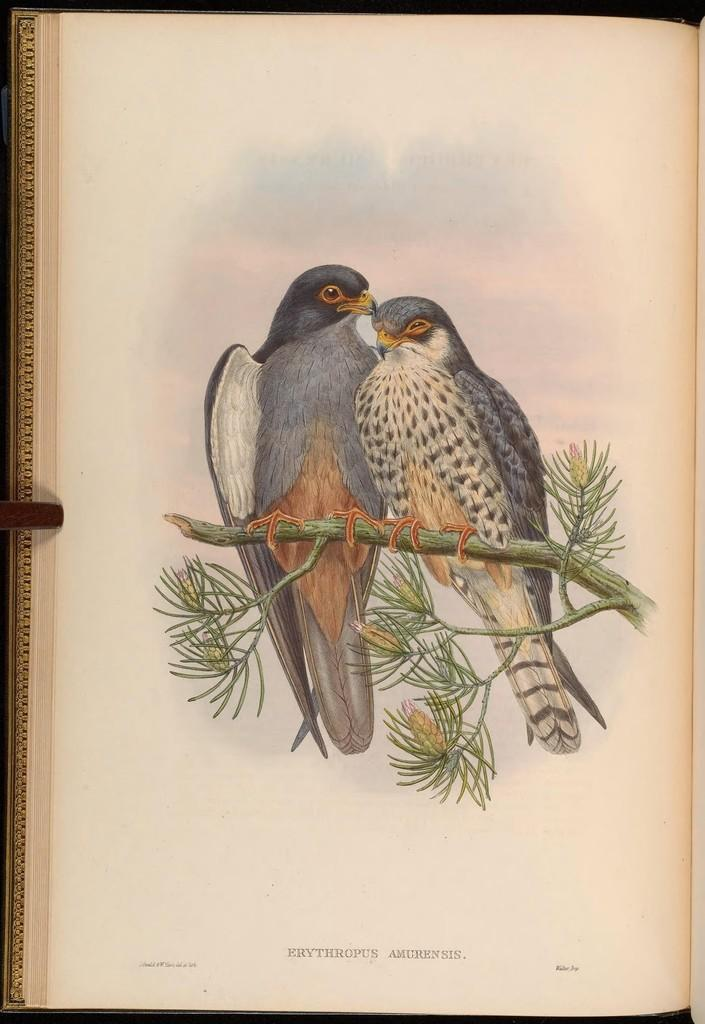What is the main subject of the image? The image contains a page from a book. What can be seen in the drawing on the book page? There is a drawing of two birds in the image. Where are the birds located in the drawing? The birds are sitting on the branch of a tree. What else is present on the book page besides the drawing? There is text at the bottom of the book page. What type of button can be seen on the branch of the tree in the image? There is no button present on the branch of the tree in the image; it features a drawing of two birds. Can you tell me how the birds are performing a flight in the image? The birds are not performing a flight in the image; they are sitting on the branch of a tree. 